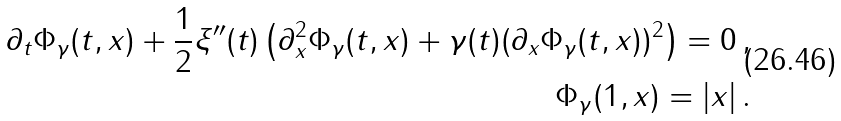Convert formula to latex. <formula><loc_0><loc_0><loc_500><loc_500>\partial _ { t } \Phi _ { \gamma } ( t , x ) + \frac { 1 } { 2 } \xi ^ { \prime \prime } ( t ) \left ( \partial _ { x } ^ { 2 } \Phi _ { \gamma } ( t , x ) + \gamma ( t ) ( \partial _ { x } \Phi _ { \gamma } ( t , x ) ) ^ { 2 } \right ) = 0 \, , \\ \Phi _ { \gamma } ( 1 , x ) = | x | \, .</formula> 